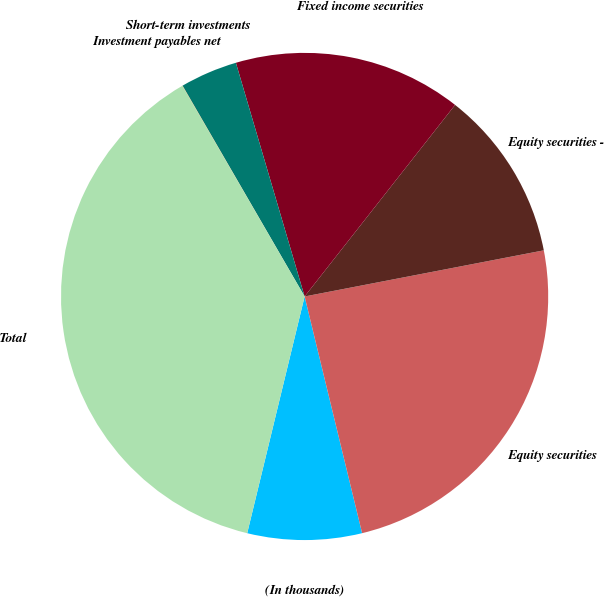<chart> <loc_0><loc_0><loc_500><loc_500><pie_chart><fcel>(In thousands)<fcel>Equity securities<fcel>Equity securities -<fcel>Fixed income securities<fcel>Short-term investments<fcel>Investment payables net<fcel>Total<nl><fcel>7.58%<fcel>24.24%<fcel>11.37%<fcel>15.15%<fcel>3.8%<fcel>0.02%<fcel>37.84%<nl></chart> 